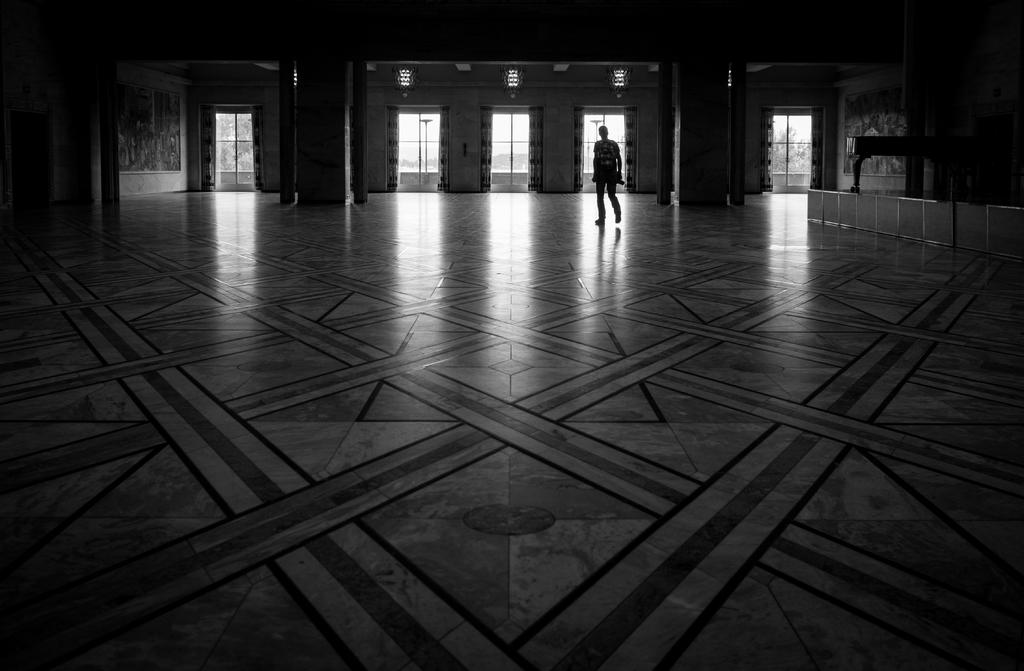What is at the bottom of the image? There is a floor at the bottom of the image. What can be seen in the middle of the image? There is a person standing in the middle of the image. What is visible in the background of the image? There is a wall in the background of the image. What feature does the wall have? The wall has glass doors. What type of meat is being cooked on the grill in the image? There is no grill or meat present in the image. How many pizzas are being prepared on the counter in the image? There is no counter or pizzas present in the image. 